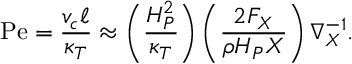<formula> <loc_0><loc_0><loc_500><loc_500>P e = { \frac { v _ { c } \ell } { \kappa _ { T } } } \approx \left ( { \frac { H _ { P } ^ { 2 } } { \kappa _ { T } } } \right ) \left ( { \frac { 2 F _ { X } } { \rho H _ { P } X } } \right ) \nabla _ { X } ^ { - 1 } .</formula> 